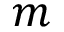<formula> <loc_0><loc_0><loc_500><loc_500>m</formula> 